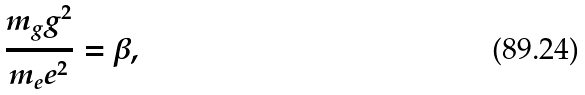<formula> <loc_0><loc_0><loc_500><loc_500>\frac { m _ { g } g ^ { 2 } } { m _ { e } e ^ { 2 } } = \beta ,</formula> 